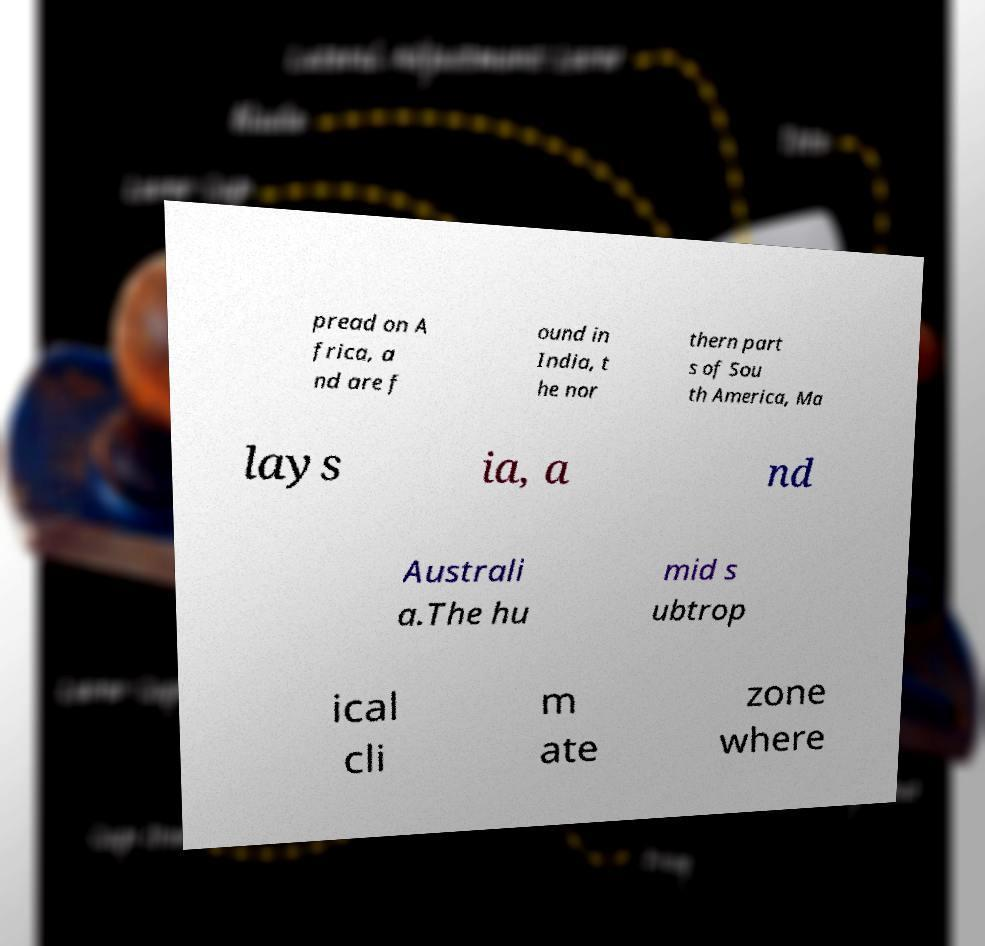Could you assist in decoding the text presented in this image and type it out clearly? pread on A frica, a nd are f ound in India, t he nor thern part s of Sou th America, Ma lays ia, a nd Australi a.The hu mid s ubtrop ical cli m ate zone where 